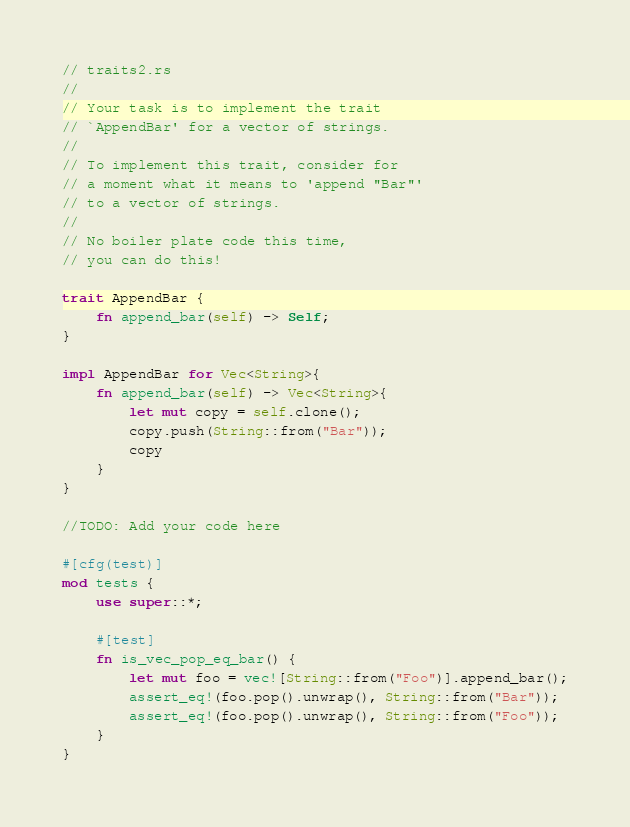<code> <loc_0><loc_0><loc_500><loc_500><_Rust_>// traits2.rs
//
// Your task is to implement the trait
// `AppendBar' for a vector of strings.
//
// To implement this trait, consider for
// a moment what it means to 'append "Bar"'
// to a vector of strings.
//
// No boiler plate code this time,
// you can do this!

trait AppendBar {
    fn append_bar(self) -> Self;
}

impl AppendBar for Vec<String>{
    fn append_bar(self) -> Vec<String>{
        let mut copy = self.clone();
        copy.push(String::from("Bar"));
        copy
    }
}

//TODO: Add your code here

#[cfg(test)]
mod tests {
    use super::*;

    #[test]
    fn is_vec_pop_eq_bar() {
        let mut foo = vec![String::from("Foo")].append_bar();
        assert_eq!(foo.pop().unwrap(), String::from("Bar"));
        assert_eq!(foo.pop().unwrap(), String::from("Foo"));
    }
}
</code> 